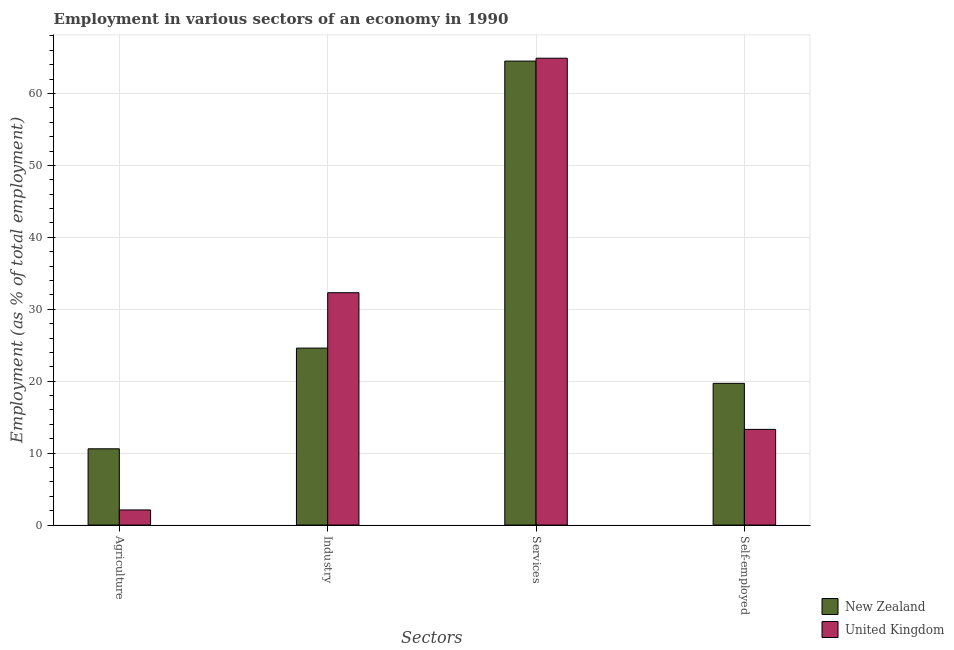How many groups of bars are there?
Your answer should be very brief. 4. Are the number of bars per tick equal to the number of legend labels?
Keep it short and to the point. Yes. Are the number of bars on each tick of the X-axis equal?
Give a very brief answer. Yes. How many bars are there on the 1st tick from the left?
Make the answer very short. 2. What is the label of the 1st group of bars from the left?
Keep it short and to the point. Agriculture. What is the percentage of workers in services in United Kingdom?
Provide a succinct answer. 64.9. Across all countries, what is the maximum percentage of workers in agriculture?
Give a very brief answer. 10.6. Across all countries, what is the minimum percentage of workers in industry?
Make the answer very short. 24.6. In which country was the percentage of workers in agriculture maximum?
Offer a terse response. New Zealand. In which country was the percentage of self employed workers minimum?
Keep it short and to the point. United Kingdom. What is the total percentage of workers in industry in the graph?
Your response must be concise. 56.9. What is the difference between the percentage of workers in industry in New Zealand and that in United Kingdom?
Offer a very short reply. -7.7. What is the difference between the percentage of workers in services in New Zealand and the percentage of workers in agriculture in United Kingdom?
Offer a terse response. 62.4. What is the average percentage of workers in services per country?
Ensure brevity in your answer.  64.7. What is the difference between the percentage of self employed workers and percentage of workers in agriculture in New Zealand?
Make the answer very short. 9.1. What is the ratio of the percentage of workers in industry in New Zealand to that in United Kingdom?
Your answer should be very brief. 0.76. Is the percentage of self employed workers in New Zealand less than that in United Kingdom?
Offer a terse response. No. Is the difference between the percentage of self employed workers in United Kingdom and New Zealand greater than the difference between the percentage of workers in services in United Kingdom and New Zealand?
Offer a very short reply. No. What is the difference between the highest and the second highest percentage of workers in industry?
Provide a succinct answer. 7.7. What is the difference between the highest and the lowest percentage of self employed workers?
Your response must be concise. 6.4. Is it the case that in every country, the sum of the percentage of workers in services and percentage of self employed workers is greater than the sum of percentage of workers in agriculture and percentage of workers in industry?
Make the answer very short. No. What does the 1st bar from the right in Self-employed represents?
Offer a very short reply. United Kingdom. Is it the case that in every country, the sum of the percentage of workers in agriculture and percentage of workers in industry is greater than the percentage of workers in services?
Offer a very short reply. No. Are all the bars in the graph horizontal?
Provide a succinct answer. No. How many countries are there in the graph?
Make the answer very short. 2. What is the difference between two consecutive major ticks on the Y-axis?
Make the answer very short. 10. How many legend labels are there?
Make the answer very short. 2. How are the legend labels stacked?
Keep it short and to the point. Vertical. What is the title of the graph?
Make the answer very short. Employment in various sectors of an economy in 1990. What is the label or title of the X-axis?
Your answer should be compact. Sectors. What is the label or title of the Y-axis?
Keep it short and to the point. Employment (as % of total employment). What is the Employment (as % of total employment) of New Zealand in Agriculture?
Provide a short and direct response. 10.6. What is the Employment (as % of total employment) of United Kingdom in Agriculture?
Your response must be concise. 2.1. What is the Employment (as % of total employment) in New Zealand in Industry?
Make the answer very short. 24.6. What is the Employment (as % of total employment) of United Kingdom in Industry?
Make the answer very short. 32.3. What is the Employment (as % of total employment) of New Zealand in Services?
Keep it short and to the point. 64.5. What is the Employment (as % of total employment) in United Kingdom in Services?
Make the answer very short. 64.9. What is the Employment (as % of total employment) in New Zealand in Self-employed?
Give a very brief answer. 19.7. What is the Employment (as % of total employment) in United Kingdom in Self-employed?
Your answer should be very brief. 13.3. Across all Sectors, what is the maximum Employment (as % of total employment) in New Zealand?
Your answer should be compact. 64.5. Across all Sectors, what is the maximum Employment (as % of total employment) of United Kingdom?
Give a very brief answer. 64.9. Across all Sectors, what is the minimum Employment (as % of total employment) in New Zealand?
Provide a short and direct response. 10.6. Across all Sectors, what is the minimum Employment (as % of total employment) in United Kingdom?
Offer a terse response. 2.1. What is the total Employment (as % of total employment) of New Zealand in the graph?
Your answer should be compact. 119.4. What is the total Employment (as % of total employment) of United Kingdom in the graph?
Ensure brevity in your answer.  112.6. What is the difference between the Employment (as % of total employment) in United Kingdom in Agriculture and that in Industry?
Ensure brevity in your answer.  -30.2. What is the difference between the Employment (as % of total employment) in New Zealand in Agriculture and that in Services?
Your response must be concise. -53.9. What is the difference between the Employment (as % of total employment) in United Kingdom in Agriculture and that in Services?
Provide a succinct answer. -62.8. What is the difference between the Employment (as % of total employment) in United Kingdom in Agriculture and that in Self-employed?
Provide a short and direct response. -11.2. What is the difference between the Employment (as % of total employment) of New Zealand in Industry and that in Services?
Give a very brief answer. -39.9. What is the difference between the Employment (as % of total employment) of United Kingdom in Industry and that in Services?
Give a very brief answer. -32.6. What is the difference between the Employment (as % of total employment) of United Kingdom in Industry and that in Self-employed?
Your response must be concise. 19. What is the difference between the Employment (as % of total employment) of New Zealand in Services and that in Self-employed?
Your response must be concise. 44.8. What is the difference between the Employment (as % of total employment) in United Kingdom in Services and that in Self-employed?
Your answer should be very brief. 51.6. What is the difference between the Employment (as % of total employment) in New Zealand in Agriculture and the Employment (as % of total employment) in United Kingdom in Industry?
Ensure brevity in your answer.  -21.7. What is the difference between the Employment (as % of total employment) of New Zealand in Agriculture and the Employment (as % of total employment) of United Kingdom in Services?
Your response must be concise. -54.3. What is the difference between the Employment (as % of total employment) of New Zealand in Agriculture and the Employment (as % of total employment) of United Kingdom in Self-employed?
Keep it short and to the point. -2.7. What is the difference between the Employment (as % of total employment) in New Zealand in Industry and the Employment (as % of total employment) in United Kingdom in Services?
Provide a succinct answer. -40.3. What is the difference between the Employment (as % of total employment) in New Zealand in Industry and the Employment (as % of total employment) in United Kingdom in Self-employed?
Offer a very short reply. 11.3. What is the difference between the Employment (as % of total employment) in New Zealand in Services and the Employment (as % of total employment) in United Kingdom in Self-employed?
Your answer should be compact. 51.2. What is the average Employment (as % of total employment) of New Zealand per Sectors?
Your answer should be very brief. 29.85. What is the average Employment (as % of total employment) of United Kingdom per Sectors?
Provide a succinct answer. 28.15. What is the difference between the Employment (as % of total employment) in New Zealand and Employment (as % of total employment) in United Kingdom in Agriculture?
Keep it short and to the point. 8.5. What is the difference between the Employment (as % of total employment) in New Zealand and Employment (as % of total employment) in United Kingdom in Services?
Provide a succinct answer. -0.4. What is the ratio of the Employment (as % of total employment) of New Zealand in Agriculture to that in Industry?
Your response must be concise. 0.43. What is the ratio of the Employment (as % of total employment) of United Kingdom in Agriculture to that in Industry?
Keep it short and to the point. 0.07. What is the ratio of the Employment (as % of total employment) in New Zealand in Agriculture to that in Services?
Your answer should be very brief. 0.16. What is the ratio of the Employment (as % of total employment) in United Kingdom in Agriculture to that in Services?
Offer a terse response. 0.03. What is the ratio of the Employment (as % of total employment) of New Zealand in Agriculture to that in Self-employed?
Make the answer very short. 0.54. What is the ratio of the Employment (as % of total employment) in United Kingdom in Agriculture to that in Self-employed?
Your answer should be very brief. 0.16. What is the ratio of the Employment (as % of total employment) of New Zealand in Industry to that in Services?
Offer a terse response. 0.38. What is the ratio of the Employment (as % of total employment) in United Kingdom in Industry to that in Services?
Your response must be concise. 0.5. What is the ratio of the Employment (as % of total employment) of New Zealand in Industry to that in Self-employed?
Offer a terse response. 1.25. What is the ratio of the Employment (as % of total employment) of United Kingdom in Industry to that in Self-employed?
Your answer should be very brief. 2.43. What is the ratio of the Employment (as % of total employment) in New Zealand in Services to that in Self-employed?
Provide a short and direct response. 3.27. What is the ratio of the Employment (as % of total employment) of United Kingdom in Services to that in Self-employed?
Ensure brevity in your answer.  4.88. What is the difference between the highest and the second highest Employment (as % of total employment) in New Zealand?
Keep it short and to the point. 39.9. What is the difference between the highest and the second highest Employment (as % of total employment) of United Kingdom?
Ensure brevity in your answer.  32.6. What is the difference between the highest and the lowest Employment (as % of total employment) of New Zealand?
Your answer should be very brief. 53.9. What is the difference between the highest and the lowest Employment (as % of total employment) of United Kingdom?
Provide a short and direct response. 62.8. 